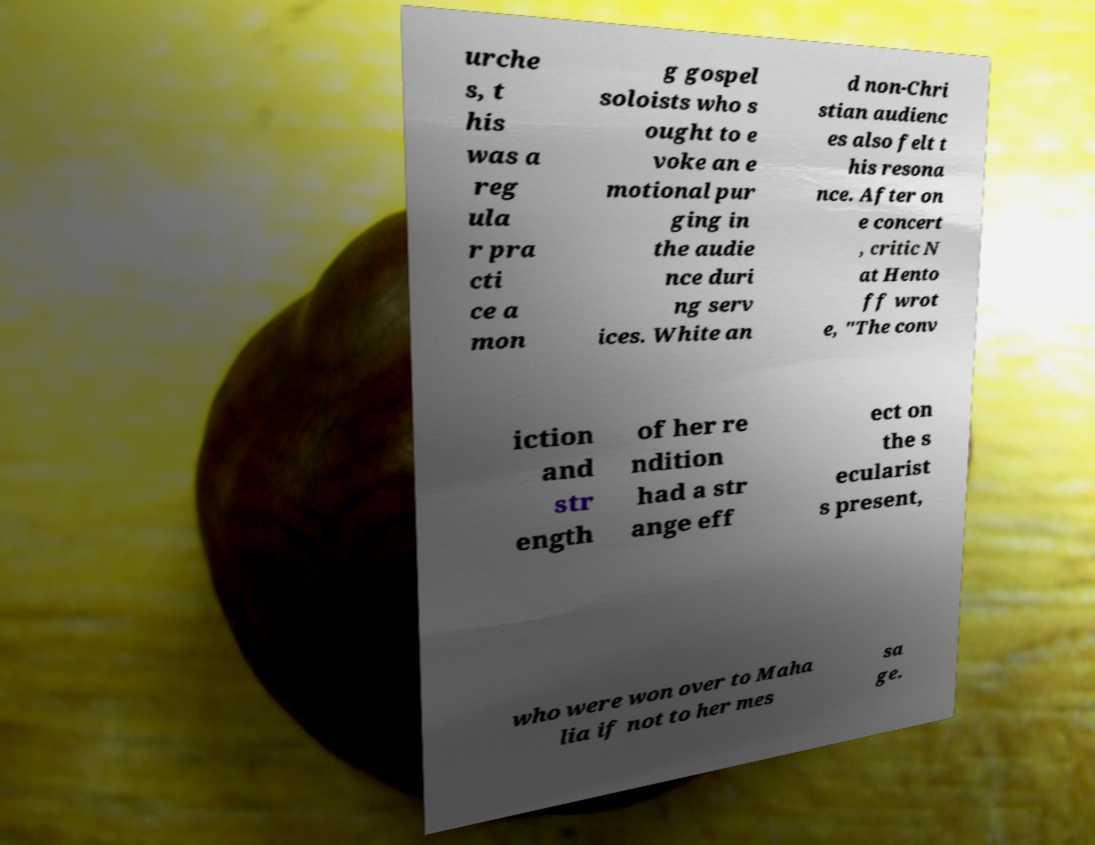Please identify and transcribe the text found in this image. urche s, t his was a reg ula r pra cti ce a mon g gospel soloists who s ought to e voke an e motional pur ging in the audie nce duri ng serv ices. White an d non-Chri stian audienc es also felt t his resona nce. After on e concert , critic N at Hento ff wrot e, "The conv iction and str ength of her re ndition had a str ange eff ect on the s ecularist s present, who were won over to Maha lia if not to her mes sa ge. 